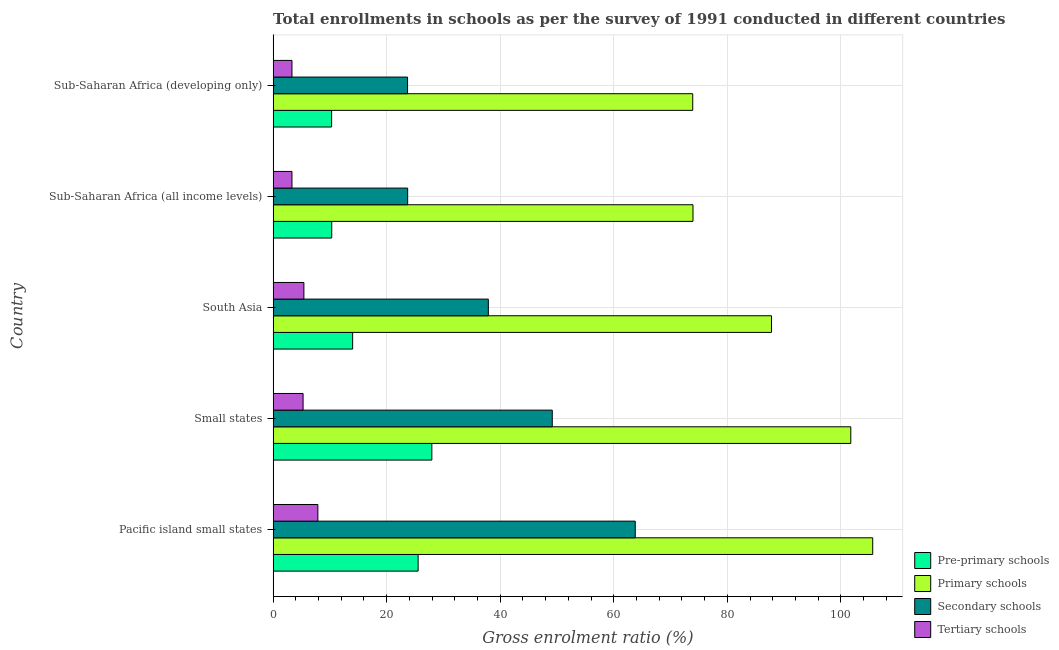How many different coloured bars are there?
Keep it short and to the point. 4. Are the number of bars per tick equal to the number of legend labels?
Ensure brevity in your answer.  Yes. Are the number of bars on each tick of the Y-axis equal?
Your answer should be very brief. Yes. How many bars are there on the 4th tick from the top?
Offer a terse response. 4. What is the label of the 2nd group of bars from the top?
Provide a succinct answer. Sub-Saharan Africa (all income levels). In how many cases, is the number of bars for a given country not equal to the number of legend labels?
Provide a short and direct response. 0. What is the gross enrolment ratio in tertiary schools in Sub-Saharan Africa (developing only)?
Give a very brief answer. 3.32. Across all countries, what is the maximum gross enrolment ratio in secondary schools?
Offer a very short reply. 63.78. Across all countries, what is the minimum gross enrolment ratio in pre-primary schools?
Your response must be concise. 10.3. In which country was the gross enrolment ratio in tertiary schools maximum?
Keep it short and to the point. Pacific island small states. In which country was the gross enrolment ratio in primary schools minimum?
Offer a terse response. Sub-Saharan Africa (developing only). What is the total gross enrolment ratio in primary schools in the graph?
Provide a short and direct response. 442.95. What is the difference between the gross enrolment ratio in tertiary schools in Sub-Saharan Africa (all income levels) and that in Sub-Saharan Africa (developing only)?
Make the answer very short. -0. What is the difference between the gross enrolment ratio in primary schools in Pacific island small states and the gross enrolment ratio in secondary schools in Sub-Saharan Africa (all income levels)?
Provide a short and direct response. 81.9. What is the average gross enrolment ratio in pre-primary schools per country?
Make the answer very short. 17.62. What is the difference between the gross enrolment ratio in primary schools and gross enrolment ratio in tertiary schools in Sub-Saharan Africa (developing only)?
Make the answer very short. 70.58. In how many countries, is the gross enrolment ratio in secondary schools greater than 52 %?
Offer a terse response. 1. What is the ratio of the gross enrolment ratio in secondary schools in Small states to that in South Asia?
Keep it short and to the point. 1.3. Is the gross enrolment ratio in primary schools in Pacific island small states less than that in Small states?
Offer a terse response. No. Is the difference between the gross enrolment ratio in primary schools in Pacific island small states and Small states greater than the difference between the gross enrolment ratio in tertiary schools in Pacific island small states and Small states?
Keep it short and to the point. Yes. What is the difference between the highest and the second highest gross enrolment ratio in tertiary schools?
Keep it short and to the point. 2.46. What is the difference between the highest and the lowest gross enrolment ratio in primary schools?
Offer a terse response. 31.7. In how many countries, is the gross enrolment ratio in tertiary schools greater than the average gross enrolment ratio in tertiary schools taken over all countries?
Provide a short and direct response. 3. Is the sum of the gross enrolment ratio in pre-primary schools in South Asia and Sub-Saharan Africa (all income levels) greater than the maximum gross enrolment ratio in primary schools across all countries?
Make the answer very short. No. What does the 4th bar from the top in Sub-Saharan Africa (developing only) represents?
Your answer should be very brief. Pre-primary schools. What does the 3rd bar from the bottom in Small states represents?
Your response must be concise. Secondary schools. Is it the case that in every country, the sum of the gross enrolment ratio in pre-primary schools and gross enrolment ratio in primary schools is greater than the gross enrolment ratio in secondary schools?
Your response must be concise. Yes. How many bars are there?
Keep it short and to the point. 20. Are the values on the major ticks of X-axis written in scientific E-notation?
Your answer should be very brief. No. Does the graph contain grids?
Your response must be concise. Yes. Where does the legend appear in the graph?
Your response must be concise. Bottom right. How many legend labels are there?
Your answer should be very brief. 4. What is the title of the graph?
Ensure brevity in your answer.  Total enrollments in schools as per the survey of 1991 conducted in different countries. What is the label or title of the X-axis?
Your answer should be very brief. Gross enrolment ratio (%). What is the label or title of the Y-axis?
Your answer should be compact. Country. What is the Gross enrolment ratio (%) in Pre-primary schools in Pacific island small states?
Offer a terse response. 25.54. What is the Gross enrolment ratio (%) in Primary schools in Pacific island small states?
Your answer should be very brief. 105.6. What is the Gross enrolment ratio (%) of Secondary schools in Pacific island small states?
Give a very brief answer. 63.78. What is the Gross enrolment ratio (%) in Tertiary schools in Pacific island small states?
Keep it short and to the point. 7.88. What is the Gross enrolment ratio (%) of Pre-primary schools in Small states?
Make the answer very short. 27.95. What is the Gross enrolment ratio (%) of Primary schools in Small states?
Your response must be concise. 101.74. What is the Gross enrolment ratio (%) in Secondary schools in Small states?
Ensure brevity in your answer.  49.16. What is the Gross enrolment ratio (%) of Tertiary schools in Small states?
Your answer should be compact. 5.28. What is the Gross enrolment ratio (%) in Pre-primary schools in South Asia?
Ensure brevity in your answer.  14. What is the Gross enrolment ratio (%) in Primary schools in South Asia?
Give a very brief answer. 87.77. What is the Gross enrolment ratio (%) of Secondary schools in South Asia?
Give a very brief answer. 37.9. What is the Gross enrolment ratio (%) of Tertiary schools in South Asia?
Your response must be concise. 5.42. What is the Gross enrolment ratio (%) in Pre-primary schools in Sub-Saharan Africa (all income levels)?
Provide a succinct answer. 10.32. What is the Gross enrolment ratio (%) in Primary schools in Sub-Saharan Africa (all income levels)?
Offer a terse response. 73.94. What is the Gross enrolment ratio (%) of Secondary schools in Sub-Saharan Africa (all income levels)?
Your answer should be compact. 23.69. What is the Gross enrolment ratio (%) of Tertiary schools in Sub-Saharan Africa (all income levels)?
Your answer should be compact. 3.32. What is the Gross enrolment ratio (%) of Pre-primary schools in Sub-Saharan Africa (developing only)?
Your answer should be very brief. 10.3. What is the Gross enrolment ratio (%) of Primary schools in Sub-Saharan Africa (developing only)?
Your response must be concise. 73.9. What is the Gross enrolment ratio (%) in Secondary schools in Sub-Saharan Africa (developing only)?
Give a very brief answer. 23.68. What is the Gross enrolment ratio (%) of Tertiary schools in Sub-Saharan Africa (developing only)?
Provide a succinct answer. 3.32. Across all countries, what is the maximum Gross enrolment ratio (%) of Pre-primary schools?
Make the answer very short. 27.95. Across all countries, what is the maximum Gross enrolment ratio (%) in Primary schools?
Give a very brief answer. 105.6. Across all countries, what is the maximum Gross enrolment ratio (%) of Secondary schools?
Offer a very short reply. 63.78. Across all countries, what is the maximum Gross enrolment ratio (%) in Tertiary schools?
Ensure brevity in your answer.  7.88. Across all countries, what is the minimum Gross enrolment ratio (%) of Pre-primary schools?
Provide a succinct answer. 10.3. Across all countries, what is the minimum Gross enrolment ratio (%) of Primary schools?
Ensure brevity in your answer.  73.9. Across all countries, what is the minimum Gross enrolment ratio (%) of Secondary schools?
Give a very brief answer. 23.68. Across all countries, what is the minimum Gross enrolment ratio (%) of Tertiary schools?
Your answer should be very brief. 3.32. What is the total Gross enrolment ratio (%) of Pre-primary schools in the graph?
Offer a very short reply. 88.12. What is the total Gross enrolment ratio (%) of Primary schools in the graph?
Make the answer very short. 442.95. What is the total Gross enrolment ratio (%) of Secondary schools in the graph?
Your answer should be very brief. 198.21. What is the total Gross enrolment ratio (%) in Tertiary schools in the graph?
Your answer should be compact. 25.21. What is the difference between the Gross enrolment ratio (%) of Pre-primary schools in Pacific island small states and that in Small states?
Provide a short and direct response. -2.41. What is the difference between the Gross enrolment ratio (%) of Primary schools in Pacific island small states and that in Small states?
Your answer should be compact. 3.86. What is the difference between the Gross enrolment ratio (%) in Secondary schools in Pacific island small states and that in Small states?
Offer a very short reply. 14.62. What is the difference between the Gross enrolment ratio (%) of Tertiary schools in Pacific island small states and that in Small states?
Ensure brevity in your answer.  2.6. What is the difference between the Gross enrolment ratio (%) of Pre-primary schools in Pacific island small states and that in South Asia?
Your answer should be compact. 11.53. What is the difference between the Gross enrolment ratio (%) in Primary schools in Pacific island small states and that in South Asia?
Offer a very short reply. 17.83. What is the difference between the Gross enrolment ratio (%) of Secondary schools in Pacific island small states and that in South Asia?
Make the answer very short. 25.87. What is the difference between the Gross enrolment ratio (%) in Tertiary schools in Pacific island small states and that in South Asia?
Offer a terse response. 2.46. What is the difference between the Gross enrolment ratio (%) of Pre-primary schools in Pacific island small states and that in Sub-Saharan Africa (all income levels)?
Keep it short and to the point. 15.21. What is the difference between the Gross enrolment ratio (%) in Primary schools in Pacific island small states and that in Sub-Saharan Africa (all income levels)?
Your response must be concise. 31.65. What is the difference between the Gross enrolment ratio (%) of Secondary schools in Pacific island small states and that in Sub-Saharan Africa (all income levels)?
Your answer should be compact. 40.08. What is the difference between the Gross enrolment ratio (%) in Tertiary schools in Pacific island small states and that in Sub-Saharan Africa (all income levels)?
Keep it short and to the point. 4.56. What is the difference between the Gross enrolment ratio (%) in Pre-primary schools in Pacific island small states and that in Sub-Saharan Africa (developing only)?
Your answer should be very brief. 15.23. What is the difference between the Gross enrolment ratio (%) in Primary schools in Pacific island small states and that in Sub-Saharan Africa (developing only)?
Provide a short and direct response. 31.7. What is the difference between the Gross enrolment ratio (%) in Secondary schools in Pacific island small states and that in Sub-Saharan Africa (developing only)?
Offer a very short reply. 40.1. What is the difference between the Gross enrolment ratio (%) in Tertiary schools in Pacific island small states and that in Sub-Saharan Africa (developing only)?
Make the answer very short. 4.56. What is the difference between the Gross enrolment ratio (%) of Pre-primary schools in Small states and that in South Asia?
Your response must be concise. 13.95. What is the difference between the Gross enrolment ratio (%) in Primary schools in Small states and that in South Asia?
Ensure brevity in your answer.  13.97. What is the difference between the Gross enrolment ratio (%) in Secondary schools in Small states and that in South Asia?
Your answer should be compact. 11.26. What is the difference between the Gross enrolment ratio (%) of Tertiary schools in Small states and that in South Asia?
Provide a short and direct response. -0.14. What is the difference between the Gross enrolment ratio (%) in Pre-primary schools in Small states and that in Sub-Saharan Africa (all income levels)?
Offer a terse response. 17.63. What is the difference between the Gross enrolment ratio (%) in Primary schools in Small states and that in Sub-Saharan Africa (all income levels)?
Provide a succinct answer. 27.79. What is the difference between the Gross enrolment ratio (%) in Secondary schools in Small states and that in Sub-Saharan Africa (all income levels)?
Your answer should be very brief. 25.47. What is the difference between the Gross enrolment ratio (%) of Tertiary schools in Small states and that in Sub-Saharan Africa (all income levels)?
Your answer should be compact. 1.96. What is the difference between the Gross enrolment ratio (%) in Pre-primary schools in Small states and that in Sub-Saharan Africa (developing only)?
Offer a terse response. 17.65. What is the difference between the Gross enrolment ratio (%) in Primary schools in Small states and that in Sub-Saharan Africa (developing only)?
Offer a terse response. 27.84. What is the difference between the Gross enrolment ratio (%) of Secondary schools in Small states and that in Sub-Saharan Africa (developing only)?
Offer a terse response. 25.48. What is the difference between the Gross enrolment ratio (%) of Tertiary schools in Small states and that in Sub-Saharan Africa (developing only)?
Offer a terse response. 1.96. What is the difference between the Gross enrolment ratio (%) in Pre-primary schools in South Asia and that in Sub-Saharan Africa (all income levels)?
Ensure brevity in your answer.  3.68. What is the difference between the Gross enrolment ratio (%) in Primary schools in South Asia and that in Sub-Saharan Africa (all income levels)?
Your answer should be compact. 13.83. What is the difference between the Gross enrolment ratio (%) in Secondary schools in South Asia and that in Sub-Saharan Africa (all income levels)?
Keep it short and to the point. 14.21. What is the difference between the Gross enrolment ratio (%) of Tertiary schools in South Asia and that in Sub-Saharan Africa (all income levels)?
Provide a succinct answer. 2.1. What is the difference between the Gross enrolment ratio (%) in Pre-primary schools in South Asia and that in Sub-Saharan Africa (developing only)?
Offer a terse response. 3.7. What is the difference between the Gross enrolment ratio (%) in Primary schools in South Asia and that in Sub-Saharan Africa (developing only)?
Ensure brevity in your answer.  13.87. What is the difference between the Gross enrolment ratio (%) in Secondary schools in South Asia and that in Sub-Saharan Africa (developing only)?
Your response must be concise. 14.23. What is the difference between the Gross enrolment ratio (%) in Tertiary schools in South Asia and that in Sub-Saharan Africa (developing only)?
Your answer should be compact. 2.1. What is the difference between the Gross enrolment ratio (%) in Pre-primary schools in Sub-Saharan Africa (all income levels) and that in Sub-Saharan Africa (developing only)?
Offer a very short reply. 0.02. What is the difference between the Gross enrolment ratio (%) of Primary schools in Sub-Saharan Africa (all income levels) and that in Sub-Saharan Africa (developing only)?
Your answer should be compact. 0.04. What is the difference between the Gross enrolment ratio (%) of Secondary schools in Sub-Saharan Africa (all income levels) and that in Sub-Saharan Africa (developing only)?
Provide a short and direct response. 0.02. What is the difference between the Gross enrolment ratio (%) in Tertiary schools in Sub-Saharan Africa (all income levels) and that in Sub-Saharan Africa (developing only)?
Provide a succinct answer. -0. What is the difference between the Gross enrolment ratio (%) in Pre-primary schools in Pacific island small states and the Gross enrolment ratio (%) in Primary schools in Small states?
Your answer should be compact. -76.2. What is the difference between the Gross enrolment ratio (%) in Pre-primary schools in Pacific island small states and the Gross enrolment ratio (%) in Secondary schools in Small states?
Provide a succinct answer. -23.62. What is the difference between the Gross enrolment ratio (%) in Pre-primary schools in Pacific island small states and the Gross enrolment ratio (%) in Tertiary schools in Small states?
Keep it short and to the point. 20.26. What is the difference between the Gross enrolment ratio (%) in Primary schools in Pacific island small states and the Gross enrolment ratio (%) in Secondary schools in Small states?
Offer a terse response. 56.44. What is the difference between the Gross enrolment ratio (%) in Primary schools in Pacific island small states and the Gross enrolment ratio (%) in Tertiary schools in Small states?
Give a very brief answer. 100.32. What is the difference between the Gross enrolment ratio (%) in Secondary schools in Pacific island small states and the Gross enrolment ratio (%) in Tertiary schools in Small states?
Provide a short and direct response. 58.5. What is the difference between the Gross enrolment ratio (%) in Pre-primary schools in Pacific island small states and the Gross enrolment ratio (%) in Primary schools in South Asia?
Make the answer very short. -62.23. What is the difference between the Gross enrolment ratio (%) in Pre-primary schools in Pacific island small states and the Gross enrolment ratio (%) in Secondary schools in South Asia?
Make the answer very short. -12.37. What is the difference between the Gross enrolment ratio (%) in Pre-primary schools in Pacific island small states and the Gross enrolment ratio (%) in Tertiary schools in South Asia?
Provide a succinct answer. 20.12. What is the difference between the Gross enrolment ratio (%) in Primary schools in Pacific island small states and the Gross enrolment ratio (%) in Secondary schools in South Asia?
Make the answer very short. 67.69. What is the difference between the Gross enrolment ratio (%) of Primary schools in Pacific island small states and the Gross enrolment ratio (%) of Tertiary schools in South Asia?
Give a very brief answer. 100.18. What is the difference between the Gross enrolment ratio (%) of Secondary schools in Pacific island small states and the Gross enrolment ratio (%) of Tertiary schools in South Asia?
Offer a very short reply. 58.36. What is the difference between the Gross enrolment ratio (%) of Pre-primary schools in Pacific island small states and the Gross enrolment ratio (%) of Primary schools in Sub-Saharan Africa (all income levels)?
Make the answer very short. -48.41. What is the difference between the Gross enrolment ratio (%) in Pre-primary schools in Pacific island small states and the Gross enrolment ratio (%) in Secondary schools in Sub-Saharan Africa (all income levels)?
Offer a terse response. 1.84. What is the difference between the Gross enrolment ratio (%) in Pre-primary schools in Pacific island small states and the Gross enrolment ratio (%) in Tertiary schools in Sub-Saharan Africa (all income levels)?
Keep it short and to the point. 22.22. What is the difference between the Gross enrolment ratio (%) of Primary schools in Pacific island small states and the Gross enrolment ratio (%) of Secondary schools in Sub-Saharan Africa (all income levels)?
Give a very brief answer. 81.9. What is the difference between the Gross enrolment ratio (%) of Primary schools in Pacific island small states and the Gross enrolment ratio (%) of Tertiary schools in Sub-Saharan Africa (all income levels)?
Your answer should be compact. 102.28. What is the difference between the Gross enrolment ratio (%) in Secondary schools in Pacific island small states and the Gross enrolment ratio (%) in Tertiary schools in Sub-Saharan Africa (all income levels)?
Give a very brief answer. 60.46. What is the difference between the Gross enrolment ratio (%) in Pre-primary schools in Pacific island small states and the Gross enrolment ratio (%) in Primary schools in Sub-Saharan Africa (developing only)?
Your answer should be very brief. -48.36. What is the difference between the Gross enrolment ratio (%) in Pre-primary schools in Pacific island small states and the Gross enrolment ratio (%) in Secondary schools in Sub-Saharan Africa (developing only)?
Your response must be concise. 1.86. What is the difference between the Gross enrolment ratio (%) of Pre-primary schools in Pacific island small states and the Gross enrolment ratio (%) of Tertiary schools in Sub-Saharan Africa (developing only)?
Offer a terse response. 22.22. What is the difference between the Gross enrolment ratio (%) in Primary schools in Pacific island small states and the Gross enrolment ratio (%) in Secondary schools in Sub-Saharan Africa (developing only)?
Your response must be concise. 81.92. What is the difference between the Gross enrolment ratio (%) of Primary schools in Pacific island small states and the Gross enrolment ratio (%) of Tertiary schools in Sub-Saharan Africa (developing only)?
Offer a very short reply. 102.28. What is the difference between the Gross enrolment ratio (%) of Secondary schools in Pacific island small states and the Gross enrolment ratio (%) of Tertiary schools in Sub-Saharan Africa (developing only)?
Ensure brevity in your answer.  60.46. What is the difference between the Gross enrolment ratio (%) of Pre-primary schools in Small states and the Gross enrolment ratio (%) of Primary schools in South Asia?
Provide a short and direct response. -59.82. What is the difference between the Gross enrolment ratio (%) in Pre-primary schools in Small states and the Gross enrolment ratio (%) in Secondary schools in South Asia?
Ensure brevity in your answer.  -9.95. What is the difference between the Gross enrolment ratio (%) of Pre-primary schools in Small states and the Gross enrolment ratio (%) of Tertiary schools in South Asia?
Ensure brevity in your answer.  22.53. What is the difference between the Gross enrolment ratio (%) in Primary schools in Small states and the Gross enrolment ratio (%) in Secondary schools in South Asia?
Your response must be concise. 63.83. What is the difference between the Gross enrolment ratio (%) of Primary schools in Small states and the Gross enrolment ratio (%) of Tertiary schools in South Asia?
Offer a terse response. 96.32. What is the difference between the Gross enrolment ratio (%) of Secondary schools in Small states and the Gross enrolment ratio (%) of Tertiary schools in South Asia?
Ensure brevity in your answer.  43.74. What is the difference between the Gross enrolment ratio (%) of Pre-primary schools in Small states and the Gross enrolment ratio (%) of Primary schools in Sub-Saharan Africa (all income levels)?
Your response must be concise. -45.99. What is the difference between the Gross enrolment ratio (%) in Pre-primary schools in Small states and the Gross enrolment ratio (%) in Secondary schools in Sub-Saharan Africa (all income levels)?
Your response must be concise. 4.26. What is the difference between the Gross enrolment ratio (%) in Pre-primary schools in Small states and the Gross enrolment ratio (%) in Tertiary schools in Sub-Saharan Africa (all income levels)?
Offer a very short reply. 24.63. What is the difference between the Gross enrolment ratio (%) in Primary schools in Small states and the Gross enrolment ratio (%) in Secondary schools in Sub-Saharan Africa (all income levels)?
Give a very brief answer. 78.04. What is the difference between the Gross enrolment ratio (%) in Primary schools in Small states and the Gross enrolment ratio (%) in Tertiary schools in Sub-Saharan Africa (all income levels)?
Provide a short and direct response. 98.42. What is the difference between the Gross enrolment ratio (%) in Secondary schools in Small states and the Gross enrolment ratio (%) in Tertiary schools in Sub-Saharan Africa (all income levels)?
Offer a terse response. 45.84. What is the difference between the Gross enrolment ratio (%) of Pre-primary schools in Small states and the Gross enrolment ratio (%) of Primary schools in Sub-Saharan Africa (developing only)?
Ensure brevity in your answer.  -45.95. What is the difference between the Gross enrolment ratio (%) in Pre-primary schools in Small states and the Gross enrolment ratio (%) in Secondary schools in Sub-Saharan Africa (developing only)?
Your answer should be very brief. 4.27. What is the difference between the Gross enrolment ratio (%) in Pre-primary schools in Small states and the Gross enrolment ratio (%) in Tertiary schools in Sub-Saharan Africa (developing only)?
Your answer should be compact. 24.63. What is the difference between the Gross enrolment ratio (%) of Primary schools in Small states and the Gross enrolment ratio (%) of Secondary schools in Sub-Saharan Africa (developing only)?
Your answer should be compact. 78.06. What is the difference between the Gross enrolment ratio (%) in Primary schools in Small states and the Gross enrolment ratio (%) in Tertiary schools in Sub-Saharan Africa (developing only)?
Make the answer very short. 98.42. What is the difference between the Gross enrolment ratio (%) in Secondary schools in Small states and the Gross enrolment ratio (%) in Tertiary schools in Sub-Saharan Africa (developing only)?
Provide a succinct answer. 45.84. What is the difference between the Gross enrolment ratio (%) of Pre-primary schools in South Asia and the Gross enrolment ratio (%) of Primary schools in Sub-Saharan Africa (all income levels)?
Keep it short and to the point. -59.94. What is the difference between the Gross enrolment ratio (%) in Pre-primary schools in South Asia and the Gross enrolment ratio (%) in Secondary schools in Sub-Saharan Africa (all income levels)?
Offer a terse response. -9.69. What is the difference between the Gross enrolment ratio (%) in Pre-primary schools in South Asia and the Gross enrolment ratio (%) in Tertiary schools in Sub-Saharan Africa (all income levels)?
Offer a terse response. 10.69. What is the difference between the Gross enrolment ratio (%) of Primary schools in South Asia and the Gross enrolment ratio (%) of Secondary schools in Sub-Saharan Africa (all income levels)?
Provide a succinct answer. 64.07. What is the difference between the Gross enrolment ratio (%) of Primary schools in South Asia and the Gross enrolment ratio (%) of Tertiary schools in Sub-Saharan Africa (all income levels)?
Provide a short and direct response. 84.45. What is the difference between the Gross enrolment ratio (%) in Secondary schools in South Asia and the Gross enrolment ratio (%) in Tertiary schools in Sub-Saharan Africa (all income levels)?
Give a very brief answer. 34.59. What is the difference between the Gross enrolment ratio (%) of Pre-primary schools in South Asia and the Gross enrolment ratio (%) of Primary schools in Sub-Saharan Africa (developing only)?
Your response must be concise. -59.9. What is the difference between the Gross enrolment ratio (%) of Pre-primary schools in South Asia and the Gross enrolment ratio (%) of Secondary schools in Sub-Saharan Africa (developing only)?
Keep it short and to the point. -9.67. What is the difference between the Gross enrolment ratio (%) of Pre-primary schools in South Asia and the Gross enrolment ratio (%) of Tertiary schools in Sub-Saharan Africa (developing only)?
Provide a succinct answer. 10.68. What is the difference between the Gross enrolment ratio (%) in Primary schools in South Asia and the Gross enrolment ratio (%) in Secondary schools in Sub-Saharan Africa (developing only)?
Provide a short and direct response. 64.09. What is the difference between the Gross enrolment ratio (%) in Primary schools in South Asia and the Gross enrolment ratio (%) in Tertiary schools in Sub-Saharan Africa (developing only)?
Make the answer very short. 84.45. What is the difference between the Gross enrolment ratio (%) in Secondary schools in South Asia and the Gross enrolment ratio (%) in Tertiary schools in Sub-Saharan Africa (developing only)?
Your answer should be compact. 34.58. What is the difference between the Gross enrolment ratio (%) of Pre-primary schools in Sub-Saharan Africa (all income levels) and the Gross enrolment ratio (%) of Primary schools in Sub-Saharan Africa (developing only)?
Provide a short and direct response. -63.58. What is the difference between the Gross enrolment ratio (%) in Pre-primary schools in Sub-Saharan Africa (all income levels) and the Gross enrolment ratio (%) in Secondary schools in Sub-Saharan Africa (developing only)?
Ensure brevity in your answer.  -13.35. What is the difference between the Gross enrolment ratio (%) in Pre-primary schools in Sub-Saharan Africa (all income levels) and the Gross enrolment ratio (%) in Tertiary schools in Sub-Saharan Africa (developing only)?
Ensure brevity in your answer.  7. What is the difference between the Gross enrolment ratio (%) of Primary schools in Sub-Saharan Africa (all income levels) and the Gross enrolment ratio (%) of Secondary schools in Sub-Saharan Africa (developing only)?
Offer a terse response. 50.27. What is the difference between the Gross enrolment ratio (%) of Primary schools in Sub-Saharan Africa (all income levels) and the Gross enrolment ratio (%) of Tertiary schools in Sub-Saharan Africa (developing only)?
Give a very brief answer. 70.62. What is the difference between the Gross enrolment ratio (%) of Secondary schools in Sub-Saharan Africa (all income levels) and the Gross enrolment ratio (%) of Tertiary schools in Sub-Saharan Africa (developing only)?
Provide a short and direct response. 20.37. What is the average Gross enrolment ratio (%) of Pre-primary schools per country?
Provide a succinct answer. 17.62. What is the average Gross enrolment ratio (%) in Primary schools per country?
Provide a succinct answer. 88.59. What is the average Gross enrolment ratio (%) in Secondary schools per country?
Keep it short and to the point. 39.64. What is the average Gross enrolment ratio (%) of Tertiary schools per country?
Offer a terse response. 5.04. What is the difference between the Gross enrolment ratio (%) of Pre-primary schools and Gross enrolment ratio (%) of Primary schools in Pacific island small states?
Make the answer very short. -80.06. What is the difference between the Gross enrolment ratio (%) in Pre-primary schools and Gross enrolment ratio (%) in Secondary schools in Pacific island small states?
Offer a terse response. -38.24. What is the difference between the Gross enrolment ratio (%) in Pre-primary schools and Gross enrolment ratio (%) in Tertiary schools in Pacific island small states?
Offer a terse response. 17.66. What is the difference between the Gross enrolment ratio (%) in Primary schools and Gross enrolment ratio (%) in Secondary schools in Pacific island small states?
Your answer should be very brief. 41.82. What is the difference between the Gross enrolment ratio (%) in Primary schools and Gross enrolment ratio (%) in Tertiary schools in Pacific island small states?
Your answer should be very brief. 97.72. What is the difference between the Gross enrolment ratio (%) in Secondary schools and Gross enrolment ratio (%) in Tertiary schools in Pacific island small states?
Your answer should be very brief. 55.9. What is the difference between the Gross enrolment ratio (%) in Pre-primary schools and Gross enrolment ratio (%) in Primary schools in Small states?
Offer a very short reply. -73.79. What is the difference between the Gross enrolment ratio (%) of Pre-primary schools and Gross enrolment ratio (%) of Secondary schools in Small states?
Your response must be concise. -21.21. What is the difference between the Gross enrolment ratio (%) of Pre-primary schools and Gross enrolment ratio (%) of Tertiary schools in Small states?
Offer a terse response. 22.68. What is the difference between the Gross enrolment ratio (%) in Primary schools and Gross enrolment ratio (%) in Secondary schools in Small states?
Give a very brief answer. 52.58. What is the difference between the Gross enrolment ratio (%) in Primary schools and Gross enrolment ratio (%) in Tertiary schools in Small states?
Your answer should be very brief. 96.46. What is the difference between the Gross enrolment ratio (%) in Secondary schools and Gross enrolment ratio (%) in Tertiary schools in Small states?
Give a very brief answer. 43.88. What is the difference between the Gross enrolment ratio (%) in Pre-primary schools and Gross enrolment ratio (%) in Primary schools in South Asia?
Your answer should be compact. -73.76. What is the difference between the Gross enrolment ratio (%) in Pre-primary schools and Gross enrolment ratio (%) in Secondary schools in South Asia?
Offer a terse response. -23.9. What is the difference between the Gross enrolment ratio (%) of Pre-primary schools and Gross enrolment ratio (%) of Tertiary schools in South Asia?
Your answer should be very brief. 8.59. What is the difference between the Gross enrolment ratio (%) of Primary schools and Gross enrolment ratio (%) of Secondary schools in South Asia?
Your response must be concise. 49.86. What is the difference between the Gross enrolment ratio (%) in Primary schools and Gross enrolment ratio (%) in Tertiary schools in South Asia?
Your answer should be compact. 82.35. What is the difference between the Gross enrolment ratio (%) in Secondary schools and Gross enrolment ratio (%) in Tertiary schools in South Asia?
Make the answer very short. 32.49. What is the difference between the Gross enrolment ratio (%) of Pre-primary schools and Gross enrolment ratio (%) of Primary schools in Sub-Saharan Africa (all income levels)?
Keep it short and to the point. -63.62. What is the difference between the Gross enrolment ratio (%) of Pre-primary schools and Gross enrolment ratio (%) of Secondary schools in Sub-Saharan Africa (all income levels)?
Offer a very short reply. -13.37. What is the difference between the Gross enrolment ratio (%) of Pre-primary schools and Gross enrolment ratio (%) of Tertiary schools in Sub-Saharan Africa (all income levels)?
Your response must be concise. 7.01. What is the difference between the Gross enrolment ratio (%) of Primary schools and Gross enrolment ratio (%) of Secondary schools in Sub-Saharan Africa (all income levels)?
Make the answer very short. 50.25. What is the difference between the Gross enrolment ratio (%) in Primary schools and Gross enrolment ratio (%) in Tertiary schools in Sub-Saharan Africa (all income levels)?
Keep it short and to the point. 70.62. What is the difference between the Gross enrolment ratio (%) in Secondary schools and Gross enrolment ratio (%) in Tertiary schools in Sub-Saharan Africa (all income levels)?
Your answer should be compact. 20.38. What is the difference between the Gross enrolment ratio (%) of Pre-primary schools and Gross enrolment ratio (%) of Primary schools in Sub-Saharan Africa (developing only)?
Provide a succinct answer. -63.6. What is the difference between the Gross enrolment ratio (%) of Pre-primary schools and Gross enrolment ratio (%) of Secondary schools in Sub-Saharan Africa (developing only)?
Your response must be concise. -13.37. What is the difference between the Gross enrolment ratio (%) of Pre-primary schools and Gross enrolment ratio (%) of Tertiary schools in Sub-Saharan Africa (developing only)?
Your response must be concise. 6.98. What is the difference between the Gross enrolment ratio (%) in Primary schools and Gross enrolment ratio (%) in Secondary schools in Sub-Saharan Africa (developing only)?
Offer a terse response. 50.22. What is the difference between the Gross enrolment ratio (%) of Primary schools and Gross enrolment ratio (%) of Tertiary schools in Sub-Saharan Africa (developing only)?
Offer a very short reply. 70.58. What is the difference between the Gross enrolment ratio (%) of Secondary schools and Gross enrolment ratio (%) of Tertiary schools in Sub-Saharan Africa (developing only)?
Your answer should be very brief. 20.36. What is the ratio of the Gross enrolment ratio (%) of Pre-primary schools in Pacific island small states to that in Small states?
Offer a very short reply. 0.91. What is the ratio of the Gross enrolment ratio (%) in Primary schools in Pacific island small states to that in Small states?
Your answer should be very brief. 1.04. What is the ratio of the Gross enrolment ratio (%) in Secondary schools in Pacific island small states to that in Small states?
Offer a terse response. 1.3. What is the ratio of the Gross enrolment ratio (%) of Tertiary schools in Pacific island small states to that in Small states?
Give a very brief answer. 1.49. What is the ratio of the Gross enrolment ratio (%) in Pre-primary schools in Pacific island small states to that in South Asia?
Provide a short and direct response. 1.82. What is the ratio of the Gross enrolment ratio (%) in Primary schools in Pacific island small states to that in South Asia?
Keep it short and to the point. 1.2. What is the ratio of the Gross enrolment ratio (%) in Secondary schools in Pacific island small states to that in South Asia?
Offer a very short reply. 1.68. What is the ratio of the Gross enrolment ratio (%) in Tertiary schools in Pacific island small states to that in South Asia?
Your answer should be compact. 1.45. What is the ratio of the Gross enrolment ratio (%) in Pre-primary schools in Pacific island small states to that in Sub-Saharan Africa (all income levels)?
Give a very brief answer. 2.47. What is the ratio of the Gross enrolment ratio (%) of Primary schools in Pacific island small states to that in Sub-Saharan Africa (all income levels)?
Offer a terse response. 1.43. What is the ratio of the Gross enrolment ratio (%) in Secondary schools in Pacific island small states to that in Sub-Saharan Africa (all income levels)?
Provide a succinct answer. 2.69. What is the ratio of the Gross enrolment ratio (%) of Tertiary schools in Pacific island small states to that in Sub-Saharan Africa (all income levels)?
Give a very brief answer. 2.37. What is the ratio of the Gross enrolment ratio (%) in Pre-primary schools in Pacific island small states to that in Sub-Saharan Africa (developing only)?
Ensure brevity in your answer.  2.48. What is the ratio of the Gross enrolment ratio (%) of Primary schools in Pacific island small states to that in Sub-Saharan Africa (developing only)?
Your response must be concise. 1.43. What is the ratio of the Gross enrolment ratio (%) of Secondary schools in Pacific island small states to that in Sub-Saharan Africa (developing only)?
Provide a succinct answer. 2.69. What is the ratio of the Gross enrolment ratio (%) of Tertiary schools in Pacific island small states to that in Sub-Saharan Africa (developing only)?
Provide a succinct answer. 2.37. What is the ratio of the Gross enrolment ratio (%) of Pre-primary schools in Small states to that in South Asia?
Give a very brief answer. 2. What is the ratio of the Gross enrolment ratio (%) of Primary schools in Small states to that in South Asia?
Provide a succinct answer. 1.16. What is the ratio of the Gross enrolment ratio (%) of Secondary schools in Small states to that in South Asia?
Provide a short and direct response. 1.3. What is the ratio of the Gross enrolment ratio (%) in Tertiary schools in Small states to that in South Asia?
Ensure brevity in your answer.  0.97. What is the ratio of the Gross enrolment ratio (%) of Pre-primary schools in Small states to that in Sub-Saharan Africa (all income levels)?
Provide a succinct answer. 2.71. What is the ratio of the Gross enrolment ratio (%) of Primary schools in Small states to that in Sub-Saharan Africa (all income levels)?
Ensure brevity in your answer.  1.38. What is the ratio of the Gross enrolment ratio (%) of Secondary schools in Small states to that in Sub-Saharan Africa (all income levels)?
Make the answer very short. 2.07. What is the ratio of the Gross enrolment ratio (%) of Tertiary schools in Small states to that in Sub-Saharan Africa (all income levels)?
Offer a very short reply. 1.59. What is the ratio of the Gross enrolment ratio (%) in Pre-primary schools in Small states to that in Sub-Saharan Africa (developing only)?
Give a very brief answer. 2.71. What is the ratio of the Gross enrolment ratio (%) in Primary schools in Small states to that in Sub-Saharan Africa (developing only)?
Offer a terse response. 1.38. What is the ratio of the Gross enrolment ratio (%) of Secondary schools in Small states to that in Sub-Saharan Africa (developing only)?
Ensure brevity in your answer.  2.08. What is the ratio of the Gross enrolment ratio (%) of Tertiary schools in Small states to that in Sub-Saharan Africa (developing only)?
Your response must be concise. 1.59. What is the ratio of the Gross enrolment ratio (%) in Pre-primary schools in South Asia to that in Sub-Saharan Africa (all income levels)?
Keep it short and to the point. 1.36. What is the ratio of the Gross enrolment ratio (%) in Primary schools in South Asia to that in Sub-Saharan Africa (all income levels)?
Provide a short and direct response. 1.19. What is the ratio of the Gross enrolment ratio (%) of Secondary schools in South Asia to that in Sub-Saharan Africa (all income levels)?
Provide a succinct answer. 1.6. What is the ratio of the Gross enrolment ratio (%) in Tertiary schools in South Asia to that in Sub-Saharan Africa (all income levels)?
Provide a short and direct response. 1.63. What is the ratio of the Gross enrolment ratio (%) of Pre-primary schools in South Asia to that in Sub-Saharan Africa (developing only)?
Provide a short and direct response. 1.36. What is the ratio of the Gross enrolment ratio (%) of Primary schools in South Asia to that in Sub-Saharan Africa (developing only)?
Offer a terse response. 1.19. What is the ratio of the Gross enrolment ratio (%) of Secondary schools in South Asia to that in Sub-Saharan Africa (developing only)?
Offer a very short reply. 1.6. What is the ratio of the Gross enrolment ratio (%) in Tertiary schools in South Asia to that in Sub-Saharan Africa (developing only)?
Keep it short and to the point. 1.63. What is the ratio of the Gross enrolment ratio (%) of Pre-primary schools in Sub-Saharan Africa (all income levels) to that in Sub-Saharan Africa (developing only)?
Give a very brief answer. 1. What is the ratio of the Gross enrolment ratio (%) in Primary schools in Sub-Saharan Africa (all income levels) to that in Sub-Saharan Africa (developing only)?
Offer a very short reply. 1. What is the ratio of the Gross enrolment ratio (%) in Secondary schools in Sub-Saharan Africa (all income levels) to that in Sub-Saharan Africa (developing only)?
Your answer should be compact. 1. What is the ratio of the Gross enrolment ratio (%) of Tertiary schools in Sub-Saharan Africa (all income levels) to that in Sub-Saharan Africa (developing only)?
Provide a short and direct response. 1. What is the difference between the highest and the second highest Gross enrolment ratio (%) in Pre-primary schools?
Provide a short and direct response. 2.41. What is the difference between the highest and the second highest Gross enrolment ratio (%) in Primary schools?
Ensure brevity in your answer.  3.86. What is the difference between the highest and the second highest Gross enrolment ratio (%) of Secondary schools?
Ensure brevity in your answer.  14.62. What is the difference between the highest and the second highest Gross enrolment ratio (%) in Tertiary schools?
Your answer should be very brief. 2.46. What is the difference between the highest and the lowest Gross enrolment ratio (%) in Pre-primary schools?
Your response must be concise. 17.65. What is the difference between the highest and the lowest Gross enrolment ratio (%) of Primary schools?
Give a very brief answer. 31.7. What is the difference between the highest and the lowest Gross enrolment ratio (%) of Secondary schools?
Give a very brief answer. 40.1. What is the difference between the highest and the lowest Gross enrolment ratio (%) in Tertiary schools?
Offer a very short reply. 4.56. 